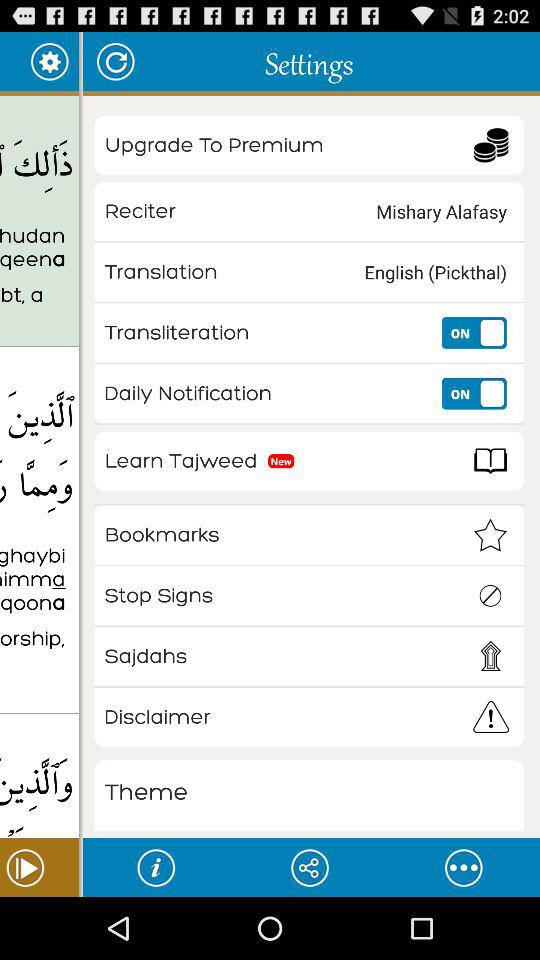What's the reciter's name? The reciter's name is Mishary Alafasy. 